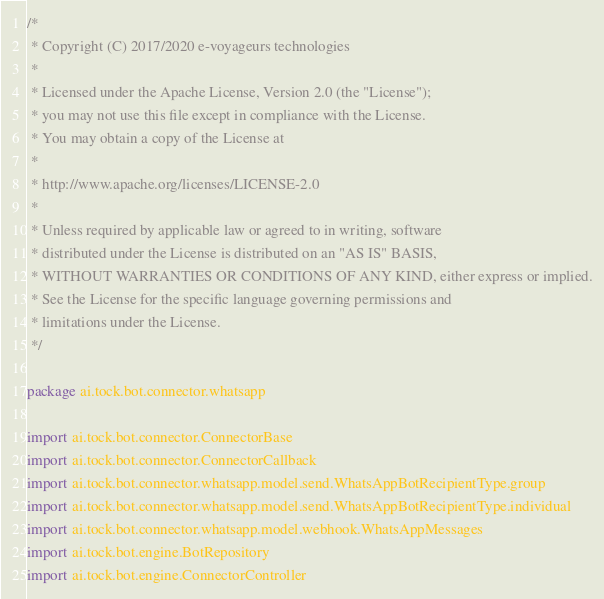<code> <loc_0><loc_0><loc_500><loc_500><_Kotlin_>/*
 * Copyright (C) 2017/2020 e-voyageurs technologies
 *
 * Licensed under the Apache License, Version 2.0 (the "License");
 * you may not use this file except in compliance with the License.
 * You may obtain a copy of the License at
 *
 * http://www.apache.org/licenses/LICENSE-2.0
 *
 * Unless required by applicable law or agreed to in writing, software
 * distributed under the License is distributed on an "AS IS" BASIS,
 * WITHOUT WARRANTIES OR CONDITIONS OF ANY KIND, either express or implied.
 * See the License for the specific language governing permissions and
 * limitations under the License.
 */

package ai.tock.bot.connector.whatsapp

import ai.tock.bot.connector.ConnectorBase
import ai.tock.bot.connector.ConnectorCallback
import ai.tock.bot.connector.whatsapp.model.send.WhatsAppBotRecipientType.group
import ai.tock.bot.connector.whatsapp.model.send.WhatsAppBotRecipientType.individual
import ai.tock.bot.connector.whatsapp.model.webhook.WhatsAppMessages
import ai.tock.bot.engine.BotRepository
import ai.tock.bot.engine.ConnectorController</code> 